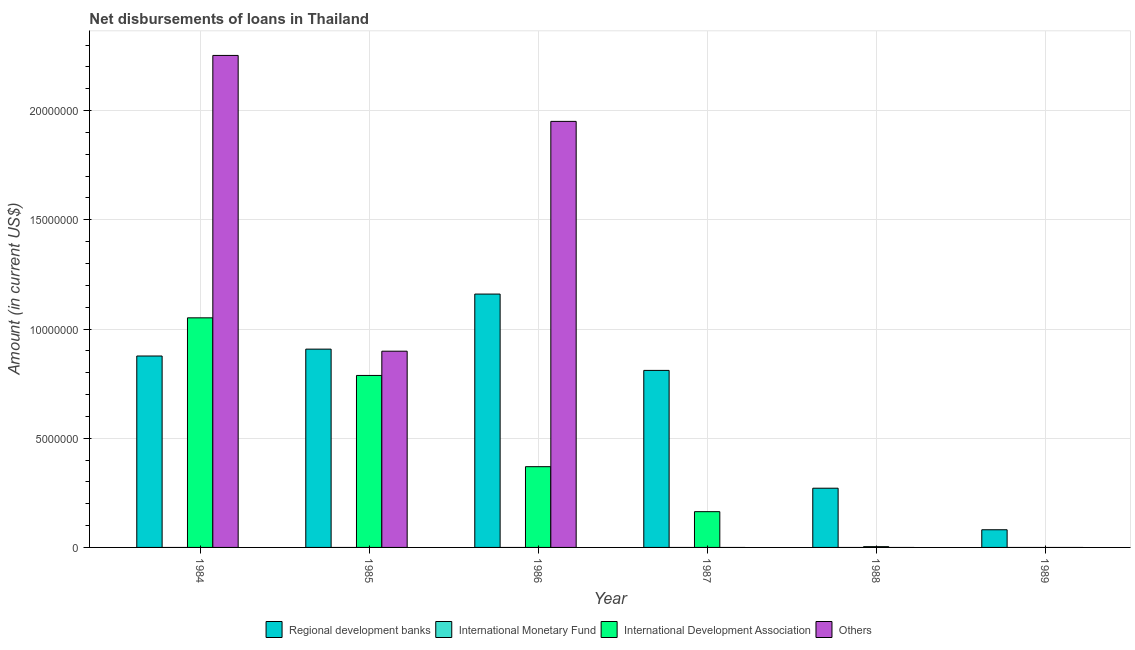Are the number of bars per tick equal to the number of legend labels?
Offer a very short reply. No. Are the number of bars on each tick of the X-axis equal?
Make the answer very short. No. What is the label of the 2nd group of bars from the left?
Your answer should be very brief. 1985. In how many cases, is the number of bars for a given year not equal to the number of legend labels?
Provide a succinct answer. 6. What is the amount of loan disimbursed by international monetary fund in 1986?
Provide a short and direct response. 0. Across all years, what is the maximum amount of loan disimbursed by international development association?
Offer a very short reply. 1.05e+07. Across all years, what is the minimum amount of loan disimbursed by regional development banks?
Give a very brief answer. 8.09e+05. What is the total amount of loan disimbursed by regional development banks in the graph?
Offer a terse response. 4.11e+07. What is the difference between the amount of loan disimbursed by regional development banks in 1984 and that in 1985?
Offer a very short reply. -3.15e+05. What is the difference between the amount of loan disimbursed by other organisations in 1989 and the amount of loan disimbursed by international development association in 1984?
Provide a succinct answer. -2.25e+07. What is the average amount of loan disimbursed by regional development banks per year?
Offer a very short reply. 6.84e+06. In the year 1984, what is the difference between the amount of loan disimbursed by other organisations and amount of loan disimbursed by regional development banks?
Keep it short and to the point. 0. In how many years, is the amount of loan disimbursed by international development association greater than 4000000 US$?
Make the answer very short. 2. What is the ratio of the amount of loan disimbursed by other organisations in 1984 to that in 1986?
Your response must be concise. 1.15. Is the amount of loan disimbursed by regional development banks in 1988 less than that in 1989?
Your response must be concise. No. Is the difference between the amount of loan disimbursed by other organisations in 1984 and 1985 greater than the difference between the amount of loan disimbursed by international development association in 1984 and 1985?
Your response must be concise. No. What is the difference between the highest and the second highest amount of loan disimbursed by international development association?
Make the answer very short. 2.64e+06. What is the difference between the highest and the lowest amount of loan disimbursed by international development association?
Make the answer very short. 1.05e+07. How many years are there in the graph?
Your response must be concise. 6. Are the values on the major ticks of Y-axis written in scientific E-notation?
Give a very brief answer. No. Does the graph contain any zero values?
Provide a succinct answer. Yes. Where does the legend appear in the graph?
Offer a terse response. Bottom center. What is the title of the graph?
Make the answer very short. Net disbursements of loans in Thailand. What is the label or title of the X-axis?
Provide a succinct answer. Year. What is the label or title of the Y-axis?
Your answer should be compact. Amount (in current US$). What is the Amount (in current US$) in Regional development banks in 1984?
Offer a very short reply. 8.76e+06. What is the Amount (in current US$) in International Monetary Fund in 1984?
Keep it short and to the point. 0. What is the Amount (in current US$) of International Development Association in 1984?
Give a very brief answer. 1.05e+07. What is the Amount (in current US$) of Others in 1984?
Provide a short and direct response. 2.25e+07. What is the Amount (in current US$) of Regional development banks in 1985?
Offer a terse response. 9.08e+06. What is the Amount (in current US$) in International Monetary Fund in 1985?
Give a very brief answer. 0. What is the Amount (in current US$) of International Development Association in 1985?
Offer a very short reply. 7.87e+06. What is the Amount (in current US$) in Others in 1985?
Make the answer very short. 8.98e+06. What is the Amount (in current US$) of Regional development banks in 1986?
Offer a terse response. 1.16e+07. What is the Amount (in current US$) in International Development Association in 1986?
Your answer should be very brief. 3.70e+06. What is the Amount (in current US$) in Others in 1986?
Keep it short and to the point. 1.95e+07. What is the Amount (in current US$) of Regional development banks in 1987?
Your response must be concise. 8.10e+06. What is the Amount (in current US$) of International Development Association in 1987?
Your answer should be very brief. 1.64e+06. What is the Amount (in current US$) of Others in 1987?
Your response must be concise. 0. What is the Amount (in current US$) in Regional development banks in 1988?
Your answer should be very brief. 2.71e+06. What is the Amount (in current US$) in International Development Association in 1988?
Offer a very short reply. 3.50e+04. What is the Amount (in current US$) in Others in 1988?
Ensure brevity in your answer.  0. What is the Amount (in current US$) in Regional development banks in 1989?
Ensure brevity in your answer.  8.09e+05. Across all years, what is the maximum Amount (in current US$) in Regional development banks?
Keep it short and to the point. 1.16e+07. Across all years, what is the maximum Amount (in current US$) of International Development Association?
Provide a succinct answer. 1.05e+07. Across all years, what is the maximum Amount (in current US$) in Others?
Keep it short and to the point. 2.25e+07. Across all years, what is the minimum Amount (in current US$) of Regional development banks?
Provide a succinct answer. 8.09e+05. Across all years, what is the minimum Amount (in current US$) in Others?
Make the answer very short. 0. What is the total Amount (in current US$) in Regional development banks in the graph?
Provide a short and direct response. 4.11e+07. What is the total Amount (in current US$) in International Development Association in the graph?
Provide a short and direct response. 2.38e+07. What is the total Amount (in current US$) in Others in the graph?
Your answer should be compact. 5.10e+07. What is the difference between the Amount (in current US$) in Regional development banks in 1984 and that in 1985?
Your answer should be very brief. -3.15e+05. What is the difference between the Amount (in current US$) of International Development Association in 1984 and that in 1985?
Ensure brevity in your answer.  2.64e+06. What is the difference between the Amount (in current US$) of Others in 1984 and that in 1985?
Provide a short and direct response. 1.35e+07. What is the difference between the Amount (in current US$) in Regional development banks in 1984 and that in 1986?
Ensure brevity in your answer.  -2.84e+06. What is the difference between the Amount (in current US$) of International Development Association in 1984 and that in 1986?
Provide a succinct answer. 6.82e+06. What is the difference between the Amount (in current US$) of Others in 1984 and that in 1986?
Make the answer very short. 3.02e+06. What is the difference between the Amount (in current US$) of Regional development banks in 1984 and that in 1987?
Make the answer very short. 6.59e+05. What is the difference between the Amount (in current US$) of International Development Association in 1984 and that in 1987?
Ensure brevity in your answer.  8.88e+06. What is the difference between the Amount (in current US$) in Regional development banks in 1984 and that in 1988?
Offer a terse response. 6.05e+06. What is the difference between the Amount (in current US$) of International Development Association in 1984 and that in 1988?
Provide a succinct answer. 1.05e+07. What is the difference between the Amount (in current US$) of Regional development banks in 1984 and that in 1989?
Your response must be concise. 7.96e+06. What is the difference between the Amount (in current US$) of Regional development banks in 1985 and that in 1986?
Give a very brief answer. -2.52e+06. What is the difference between the Amount (in current US$) of International Development Association in 1985 and that in 1986?
Provide a short and direct response. 4.18e+06. What is the difference between the Amount (in current US$) of Others in 1985 and that in 1986?
Offer a very short reply. -1.05e+07. What is the difference between the Amount (in current US$) of Regional development banks in 1985 and that in 1987?
Ensure brevity in your answer.  9.74e+05. What is the difference between the Amount (in current US$) of International Development Association in 1985 and that in 1987?
Provide a short and direct response. 6.24e+06. What is the difference between the Amount (in current US$) in Regional development banks in 1985 and that in 1988?
Your answer should be compact. 6.37e+06. What is the difference between the Amount (in current US$) of International Development Association in 1985 and that in 1988?
Offer a very short reply. 7.84e+06. What is the difference between the Amount (in current US$) in Regional development banks in 1985 and that in 1989?
Ensure brevity in your answer.  8.27e+06. What is the difference between the Amount (in current US$) of Regional development banks in 1986 and that in 1987?
Provide a succinct answer. 3.50e+06. What is the difference between the Amount (in current US$) of International Development Association in 1986 and that in 1987?
Keep it short and to the point. 2.06e+06. What is the difference between the Amount (in current US$) of Regional development banks in 1986 and that in 1988?
Provide a short and direct response. 8.89e+06. What is the difference between the Amount (in current US$) of International Development Association in 1986 and that in 1988?
Give a very brief answer. 3.66e+06. What is the difference between the Amount (in current US$) of Regional development banks in 1986 and that in 1989?
Give a very brief answer. 1.08e+07. What is the difference between the Amount (in current US$) in Regional development banks in 1987 and that in 1988?
Ensure brevity in your answer.  5.39e+06. What is the difference between the Amount (in current US$) in International Development Association in 1987 and that in 1988?
Your answer should be very brief. 1.60e+06. What is the difference between the Amount (in current US$) of Regional development banks in 1987 and that in 1989?
Your response must be concise. 7.30e+06. What is the difference between the Amount (in current US$) in Regional development banks in 1988 and that in 1989?
Offer a terse response. 1.90e+06. What is the difference between the Amount (in current US$) in Regional development banks in 1984 and the Amount (in current US$) in International Development Association in 1985?
Provide a succinct answer. 8.90e+05. What is the difference between the Amount (in current US$) in International Development Association in 1984 and the Amount (in current US$) in Others in 1985?
Offer a very short reply. 1.53e+06. What is the difference between the Amount (in current US$) in Regional development banks in 1984 and the Amount (in current US$) in International Development Association in 1986?
Give a very brief answer. 5.07e+06. What is the difference between the Amount (in current US$) of Regional development banks in 1984 and the Amount (in current US$) of Others in 1986?
Your answer should be very brief. -1.07e+07. What is the difference between the Amount (in current US$) of International Development Association in 1984 and the Amount (in current US$) of Others in 1986?
Provide a short and direct response. -8.99e+06. What is the difference between the Amount (in current US$) of Regional development banks in 1984 and the Amount (in current US$) of International Development Association in 1987?
Your answer should be compact. 7.13e+06. What is the difference between the Amount (in current US$) in Regional development banks in 1984 and the Amount (in current US$) in International Development Association in 1988?
Provide a succinct answer. 8.73e+06. What is the difference between the Amount (in current US$) of Regional development banks in 1985 and the Amount (in current US$) of International Development Association in 1986?
Offer a very short reply. 5.38e+06. What is the difference between the Amount (in current US$) in Regional development banks in 1985 and the Amount (in current US$) in Others in 1986?
Your answer should be compact. -1.04e+07. What is the difference between the Amount (in current US$) in International Development Association in 1985 and the Amount (in current US$) in Others in 1986?
Provide a short and direct response. -1.16e+07. What is the difference between the Amount (in current US$) in Regional development banks in 1985 and the Amount (in current US$) in International Development Association in 1987?
Offer a terse response. 7.44e+06. What is the difference between the Amount (in current US$) of Regional development banks in 1985 and the Amount (in current US$) of International Development Association in 1988?
Your response must be concise. 9.04e+06. What is the difference between the Amount (in current US$) of Regional development banks in 1986 and the Amount (in current US$) of International Development Association in 1987?
Offer a terse response. 9.96e+06. What is the difference between the Amount (in current US$) in Regional development banks in 1986 and the Amount (in current US$) in International Development Association in 1988?
Make the answer very short. 1.16e+07. What is the difference between the Amount (in current US$) of Regional development banks in 1987 and the Amount (in current US$) of International Development Association in 1988?
Keep it short and to the point. 8.07e+06. What is the average Amount (in current US$) in Regional development banks per year?
Your answer should be compact. 6.84e+06. What is the average Amount (in current US$) in International Development Association per year?
Offer a terse response. 3.96e+06. What is the average Amount (in current US$) in Others per year?
Ensure brevity in your answer.  8.50e+06. In the year 1984, what is the difference between the Amount (in current US$) of Regional development banks and Amount (in current US$) of International Development Association?
Keep it short and to the point. -1.75e+06. In the year 1984, what is the difference between the Amount (in current US$) of Regional development banks and Amount (in current US$) of Others?
Ensure brevity in your answer.  -1.38e+07. In the year 1984, what is the difference between the Amount (in current US$) of International Development Association and Amount (in current US$) of Others?
Offer a terse response. -1.20e+07. In the year 1985, what is the difference between the Amount (in current US$) in Regional development banks and Amount (in current US$) in International Development Association?
Make the answer very short. 1.20e+06. In the year 1985, what is the difference between the Amount (in current US$) in Regional development banks and Amount (in current US$) in Others?
Your response must be concise. 9.50e+04. In the year 1985, what is the difference between the Amount (in current US$) in International Development Association and Amount (in current US$) in Others?
Your response must be concise. -1.11e+06. In the year 1986, what is the difference between the Amount (in current US$) in Regional development banks and Amount (in current US$) in International Development Association?
Keep it short and to the point. 7.90e+06. In the year 1986, what is the difference between the Amount (in current US$) in Regional development banks and Amount (in current US$) in Others?
Your answer should be compact. -7.91e+06. In the year 1986, what is the difference between the Amount (in current US$) of International Development Association and Amount (in current US$) of Others?
Ensure brevity in your answer.  -1.58e+07. In the year 1987, what is the difference between the Amount (in current US$) of Regional development banks and Amount (in current US$) of International Development Association?
Give a very brief answer. 6.47e+06. In the year 1988, what is the difference between the Amount (in current US$) in Regional development banks and Amount (in current US$) in International Development Association?
Provide a succinct answer. 2.68e+06. What is the ratio of the Amount (in current US$) of Regional development banks in 1984 to that in 1985?
Give a very brief answer. 0.97. What is the ratio of the Amount (in current US$) of International Development Association in 1984 to that in 1985?
Keep it short and to the point. 1.33. What is the ratio of the Amount (in current US$) in Others in 1984 to that in 1985?
Keep it short and to the point. 2.51. What is the ratio of the Amount (in current US$) of Regional development banks in 1984 to that in 1986?
Provide a succinct answer. 0.76. What is the ratio of the Amount (in current US$) of International Development Association in 1984 to that in 1986?
Your answer should be compact. 2.84. What is the ratio of the Amount (in current US$) of Others in 1984 to that in 1986?
Make the answer very short. 1.15. What is the ratio of the Amount (in current US$) of Regional development banks in 1984 to that in 1987?
Offer a terse response. 1.08. What is the ratio of the Amount (in current US$) of International Development Association in 1984 to that in 1987?
Provide a short and direct response. 6.42. What is the ratio of the Amount (in current US$) of Regional development banks in 1984 to that in 1988?
Offer a very short reply. 3.23. What is the ratio of the Amount (in current US$) of International Development Association in 1984 to that in 1988?
Keep it short and to the point. 300.34. What is the ratio of the Amount (in current US$) in Regional development banks in 1984 to that in 1989?
Give a very brief answer. 10.83. What is the ratio of the Amount (in current US$) in Regional development banks in 1985 to that in 1986?
Keep it short and to the point. 0.78. What is the ratio of the Amount (in current US$) of International Development Association in 1985 to that in 1986?
Your answer should be very brief. 2.13. What is the ratio of the Amount (in current US$) of Others in 1985 to that in 1986?
Your response must be concise. 0.46. What is the ratio of the Amount (in current US$) of Regional development banks in 1985 to that in 1987?
Ensure brevity in your answer.  1.12. What is the ratio of the Amount (in current US$) in International Development Association in 1985 to that in 1987?
Your response must be concise. 4.81. What is the ratio of the Amount (in current US$) in Regional development banks in 1985 to that in 1988?
Give a very brief answer. 3.35. What is the ratio of the Amount (in current US$) of International Development Association in 1985 to that in 1988?
Your answer should be very brief. 224.97. What is the ratio of the Amount (in current US$) in Regional development banks in 1985 to that in 1989?
Your answer should be compact. 11.22. What is the ratio of the Amount (in current US$) in Regional development banks in 1986 to that in 1987?
Keep it short and to the point. 1.43. What is the ratio of the Amount (in current US$) of International Development Association in 1986 to that in 1987?
Make the answer very short. 2.26. What is the ratio of the Amount (in current US$) in Regional development banks in 1986 to that in 1988?
Ensure brevity in your answer.  4.28. What is the ratio of the Amount (in current US$) in International Development Association in 1986 to that in 1988?
Offer a very short reply. 105.63. What is the ratio of the Amount (in current US$) of Regional development banks in 1986 to that in 1989?
Make the answer very short. 14.34. What is the ratio of the Amount (in current US$) of Regional development banks in 1987 to that in 1988?
Your response must be concise. 2.99. What is the ratio of the Amount (in current US$) in International Development Association in 1987 to that in 1988?
Give a very brief answer. 46.77. What is the ratio of the Amount (in current US$) of Regional development banks in 1987 to that in 1989?
Provide a short and direct response. 10.02. What is the ratio of the Amount (in current US$) of Regional development banks in 1988 to that in 1989?
Offer a very short reply. 3.35. What is the difference between the highest and the second highest Amount (in current US$) of Regional development banks?
Keep it short and to the point. 2.52e+06. What is the difference between the highest and the second highest Amount (in current US$) in International Development Association?
Your response must be concise. 2.64e+06. What is the difference between the highest and the second highest Amount (in current US$) of Others?
Your answer should be compact. 3.02e+06. What is the difference between the highest and the lowest Amount (in current US$) in Regional development banks?
Make the answer very short. 1.08e+07. What is the difference between the highest and the lowest Amount (in current US$) of International Development Association?
Keep it short and to the point. 1.05e+07. What is the difference between the highest and the lowest Amount (in current US$) of Others?
Your response must be concise. 2.25e+07. 